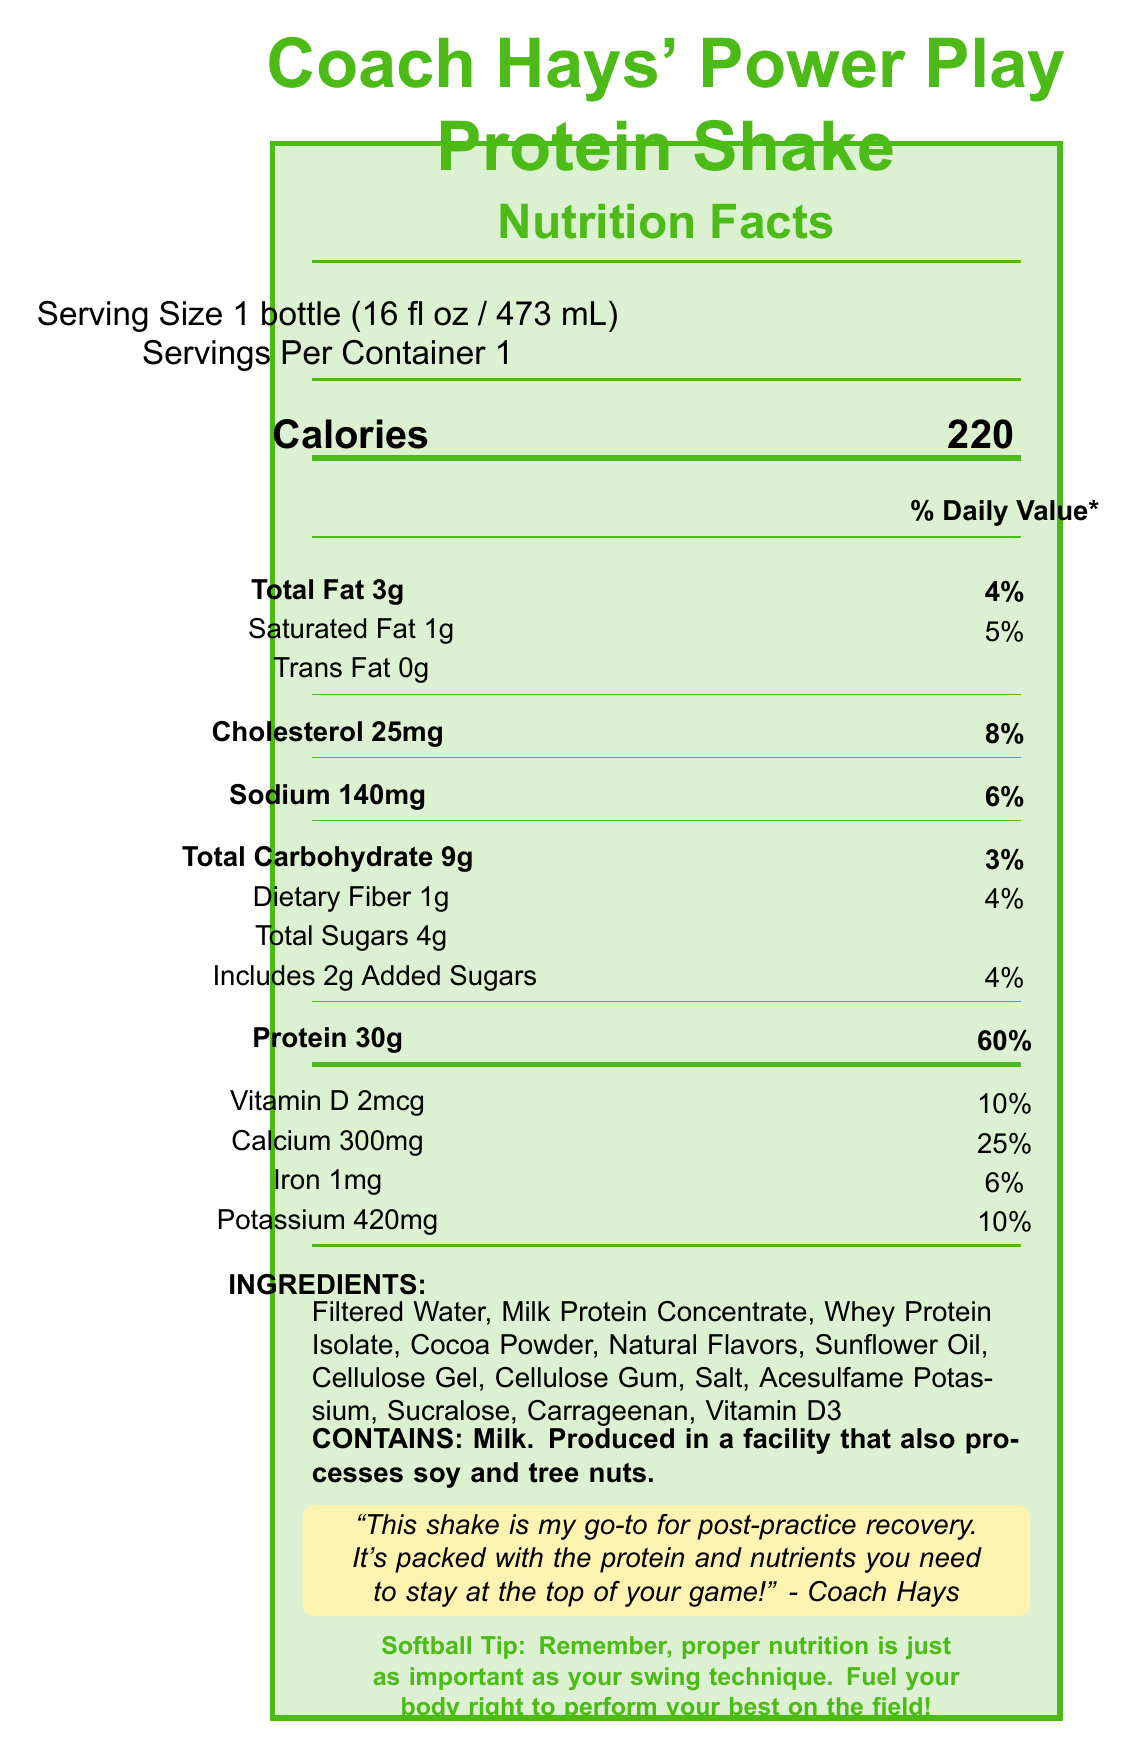what is the serving size for Coach Hays' Power Play Protein Shake? The serving size is clearly stated near the top of the nutrition facts section.
Answer: 1 bottle (16 fl oz / 473 mL) how many calories are in one serving of the protein shake? The calories per serving are indicated next to the "Calories" heading in bold numbers.
Answer: 220 how much total fat is in the protein shake? The amount of total fat is listed under the Total Fat section.
Answer: 3g what percentage of the daily value of protein does the protein shake provide? The document states that the protein amount is 30g, which is listed as 60% of the daily value.
Answer: 60% how much sodium does the shake contain? Sodium content is provided under the sodium section.
Answer: 140mg which ingredient is listed first for the power play protein shake? Ingredients are listed in descending order of predominance, and Filtered Water is the first ingredient listed.
Answer: Filtered Water which vitamin has a 25% daily value in the protein shake? A. Vitamin D B. Calcium C. Iron D. Potassium The calcium entry in the nutrient list shows that it provides 25% of the daily value.
Answer: B. Calcium how much dietary fiber does the protein shake contain? A. 0g B. 1g C. 2g D. 3g The amount of dietary fiber is listed under the Total Carbohydrate section.
Answer: B. 1g does the shake contain any trans fat? The Trans Fat section specifically states "0g".
Answer: No what is the main purpose of Coach Hays' Power Play Protein Shake according to the document? According to Coach Hays' quote, the shake is intended for post-practice recovery.
Answer: Post-practice recovery does the protein shake contain soy? The allergen information states it contains milk and is produced in a facility that also processes soy, meaning it doesn't contain soy directly.
Answer: No summarize the main idea of the document. The document describes the nutritional content, ingredients, allergen information, and provides a quote from Coach Hays endorsing the shake for post-practice recovery, emphasizing its high protein content and overall benefits for athletes.
Answer: Coach Hays' Power Play Protein Shake is a nutrition product designed for post-practice recovery, offering high protein and various nutrients to support athletic performance. The shake has a clear nutrition label, listing calories, fats, cholesterol, sodium, carbohydrates, sugars, fiber, protein, vitamins, and minerals along with allergen information and a quote from Coach Hays emphasizing its benefits. was the shake produced in a facility that processes peanuts? The allergen information does not mention peanuts; it states that the facility processes soy and tree nuts.
Answer: Not enough information following Coach Hays' tip, what is essential for performing your best on the field besides swing technique? The softball tip at the bottom reminds that proper nutrition is as crucial as swing technique for optimal performance on the field.
Answer: Proper nutrition 